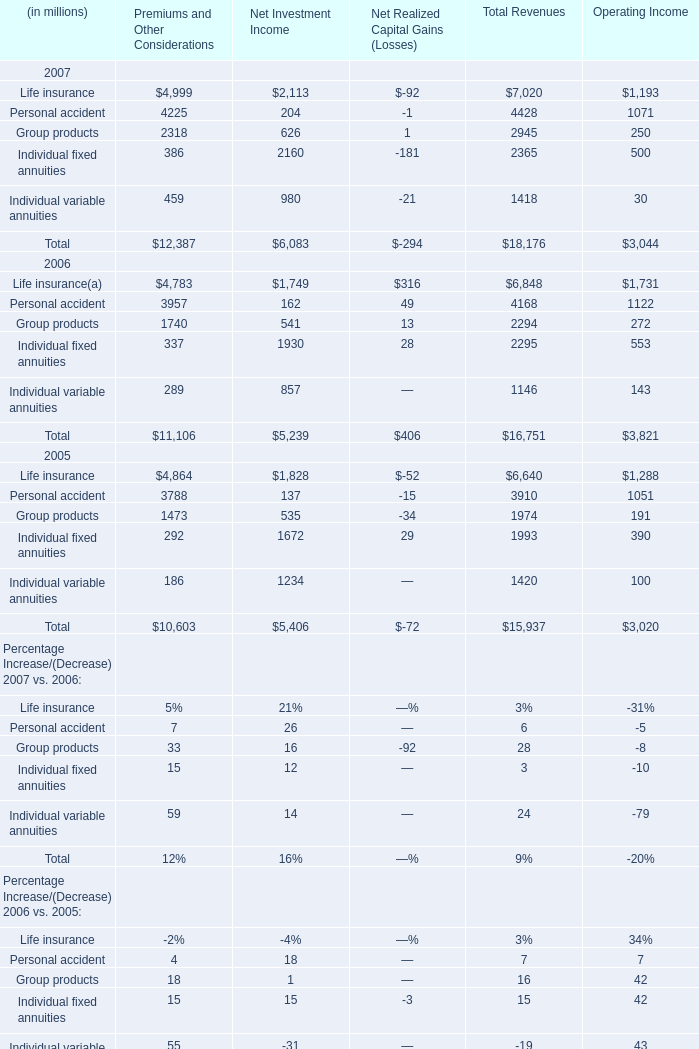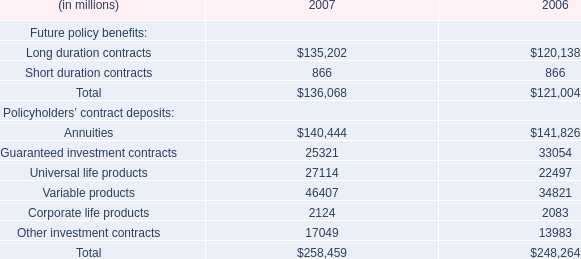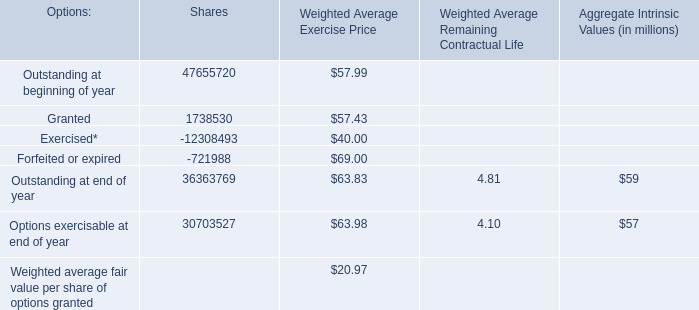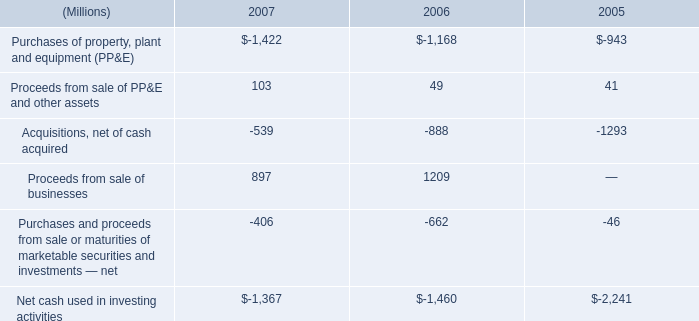what was the percentage change in the net cash used in investing activities from 2006 to 2007 
Computations: ((-1367 - -1460) / -1460)
Answer: -0.0637. 